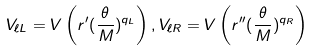Convert formula to latex. <formula><loc_0><loc_0><loc_500><loc_500>V _ { \ell L } = V \left ( r ^ { \prime } ( \frac { \theta } { M } ) ^ { q _ { L } } \right ) , V _ { \ell R } = V \left ( r ^ { \prime \prime } ( \frac { \theta } { M } ) ^ { q _ { R } } \right )</formula> 